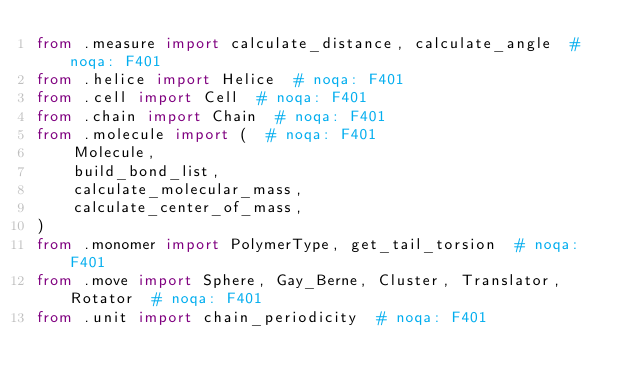<code> <loc_0><loc_0><loc_500><loc_500><_Python_>from .measure import calculate_distance, calculate_angle  # noqa: F401
from .helice import Helice  # noqa: F401
from .cell import Cell  # noqa: F401
from .chain import Chain  # noqa: F401
from .molecule import (  # noqa: F401
    Molecule,
    build_bond_list,
    calculate_molecular_mass,
    calculate_center_of_mass,
)
from .monomer import PolymerType, get_tail_torsion  # noqa: F401
from .move import Sphere, Gay_Berne, Cluster, Translator, Rotator  # noqa: F401
from .unit import chain_periodicity  # noqa: F401
</code> 